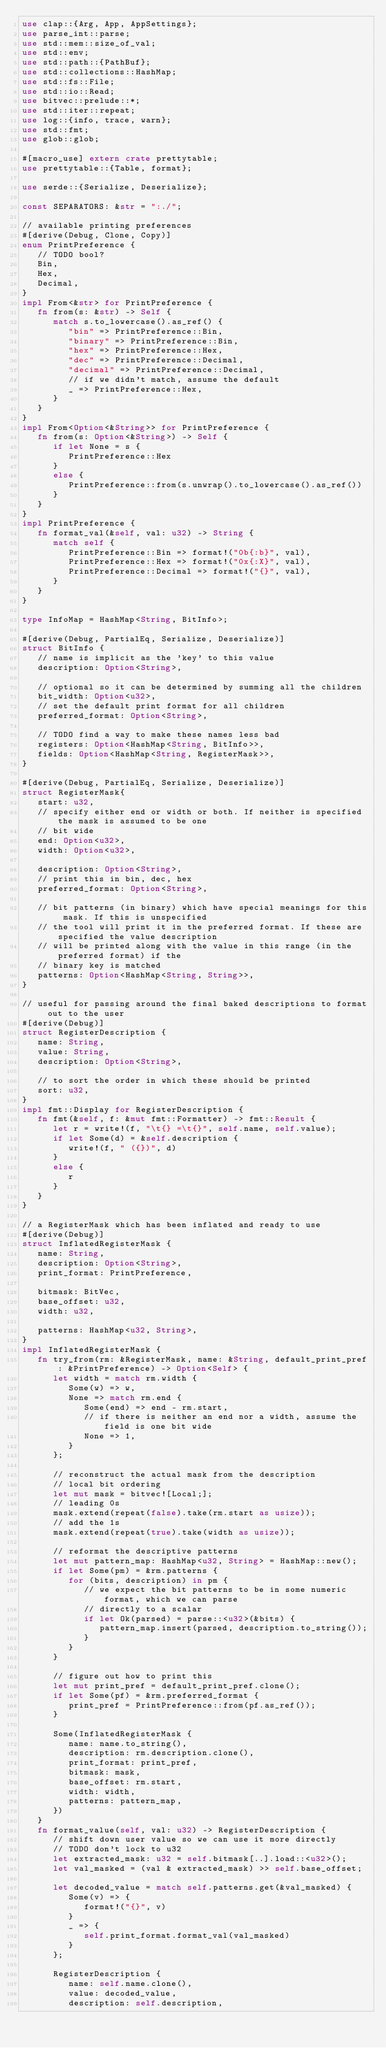Convert code to text. <code><loc_0><loc_0><loc_500><loc_500><_Rust_>use clap::{Arg, App, AppSettings};
use parse_int::parse;
use std::mem::size_of_val;
use std::env;
use std::path::{PathBuf};
use std::collections::HashMap;
use std::fs::File;
use std::io::Read;
use bitvec::prelude::*;
use std::iter::repeat;
use log::{info, trace, warn};
use std::fmt;
use glob::glob;

#[macro_use] extern crate prettytable;
use prettytable::{Table, format};

use serde::{Serialize, Deserialize};

const SEPARATORS: &str = ":./";

// available printing preferences
#[derive(Debug, Clone, Copy)]
enum PrintPreference {
   // TODO bool?
   Bin,
   Hex,
   Decimal,
}
impl From<&str> for PrintPreference {
   fn from(s: &str) -> Self {
      match s.to_lowercase().as_ref() {
         "bin" => PrintPreference::Bin,
         "binary" => PrintPreference::Bin,
         "hex" => PrintPreference::Hex,
         "dec" => PrintPreference::Decimal,
         "decimal" => PrintPreference::Decimal,
         // if we didn't match, assume the default
         _ => PrintPreference::Hex,
      }
   }
}
impl From<Option<&String>> for PrintPreference {
   fn from(s: Option<&String>) -> Self {
      if let None = s {
         PrintPreference::Hex
      }
      else {
         PrintPreference::from(s.unwrap().to_lowercase().as_ref())
      }
   }
}
impl PrintPreference {
   fn format_val(&self, val: u32) -> String {
      match self {
         PrintPreference::Bin => format!("0b{:b}", val),
         PrintPreference::Hex => format!("0x{:X}", val),
         PrintPreference::Decimal => format!("{}", val),
      }
   }
}

type InfoMap = HashMap<String, BitInfo>;

#[derive(Debug, PartialEq, Serialize, Deserialize)]
struct BitInfo {
   // name is implicit as the 'key' to this value
   description: Option<String>,

   // optional so it can be determined by summing all the children
   bit_width: Option<u32>,
   // set the default print format for all children
   preferred_format: Option<String>,

   // TODO find a way to make these names less bad
   registers: Option<HashMap<String, BitInfo>>,
   fields: Option<HashMap<String, RegisterMask>>,
}

#[derive(Debug, PartialEq, Serialize, Deserialize)]
struct RegisterMask{
   start: u32,
   // specify either end or width or both. If neither is specified the mask is assumed to be one
   // bit wide
   end: Option<u32>,
   width: Option<u32>,

   description: Option<String>,
   // print this in bin, dec, hex
   preferred_format: Option<String>,

   // bit patterns (in binary) which have special meanings for this mask. If this is unspecified
   // the tool will print it in the preferred format. If these are specified the value description
   // will be printed along with the value in this range (in the preferred format) if the
   // binary key is matched
   patterns: Option<HashMap<String, String>>,
}

// useful for passing around the final baked descriptions to format out to the user
#[derive(Debug)]
struct RegisterDescription {
   name: String,
   value: String,
   description: Option<String>,

   // to sort the order in which these should be printed
   sort: u32,
}
impl fmt::Display for RegisterDescription {
   fn fmt(&self, f: &mut fmt::Formatter) -> fmt::Result {
      let r = write!(f, "\t{} =\t{}", self.name, self.value);
      if let Some(d) = &self.description {
         write!(f, " ({})", d)
      }
      else {
         r
      }
   }
}

// a RegisterMask which has been inflated and ready to use
#[derive(Debug)]
struct InflatedRegisterMask {
   name: String,
   description: Option<String>,
   print_format: PrintPreference,

   bitmask: BitVec,
   base_offset: u32,
   width: u32,

   patterns: HashMap<u32, String>,
}
impl InflatedRegisterMask {
   fn try_from(rm: &RegisterMask, name: &String, default_print_pref: &PrintPreference) -> Option<Self> {
      let width = match rm.width {
         Some(w) => w,
         None => match rm.end {
            Some(end) => end - rm.start,
            // if there is neither an end nor a width, assume the field is one bit wide
            None => 1,
         }
      };

      // reconstruct the actual mask from the description
      // local bit ordering
      let mut mask = bitvec![Local;];
      // leading 0s
      mask.extend(repeat(false).take(rm.start as usize));
      // add the 1s
      mask.extend(repeat(true).take(width as usize));

      // reformat the descriptive patterns
      let mut pattern_map: HashMap<u32, String> = HashMap::new();
      if let Some(pm) = &rm.patterns {
         for (bits, description) in pm {
            // we expect the bit patterns to be in some numeric format, which we can parse
            // directly to a scalar
            if let Ok(parsed) = parse::<u32>(&bits) {
               pattern_map.insert(parsed, description.to_string());
            }
         }
      }

      // figure out how to print this
      let mut print_pref = default_print_pref.clone();
      if let Some(pf) = &rm.preferred_format {
         print_pref = PrintPreference::from(pf.as_ref());
      }

      Some(InflatedRegisterMask {
         name: name.to_string(),
         description: rm.description.clone(),
         print_format: print_pref,
         bitmask: mask,
         base_offset: rm.start,
         width: width,
         patterns: pattern_map,
      })
   }
   fn format_value(self, val: u32) -> RegisterDescription {
      // shift down user value so we can use it more directly
      // TODO don't lock to u32
      let extracted_mask: u32 = self.bitmask[..].load::<u32>();
      let val_masked = (val & extracted_mask) >> self.base_offset;

      let decoded_value = match self.patterns.get(&val_masked) {
         Some(v) => {
            format!("{}", v)
         }
         _ => {
            self.print_format.format_val(val_masked)
         }
      };

      RegisterDescription {
         name: self.name.clone(),
         value: decoded_value,
         description: self.description,</code> 